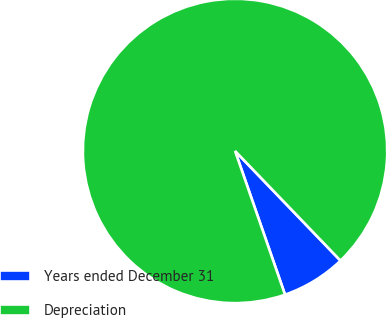Convert chart to OTSL. <chart><loc_0><loc_0><loc_500><loc_500><pie_chart><fcel>Years ended December 31<fcel>Depreciation<nl><fcel>6.86%<fcel>93.14%<nl></chart> 